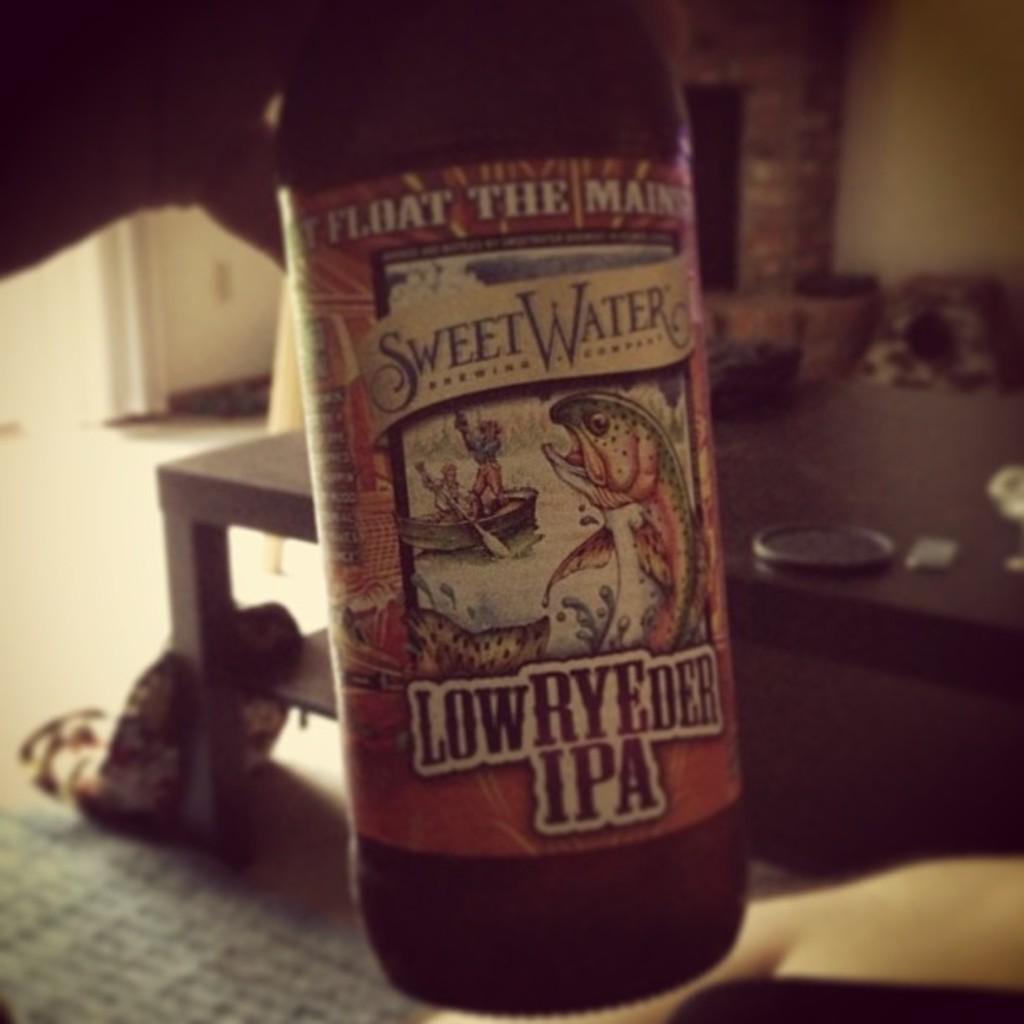What type of beer is this specifically?
Offer a very short reply. Ipa. What brand is the beer?
Your response must be concise. Sweet water. 